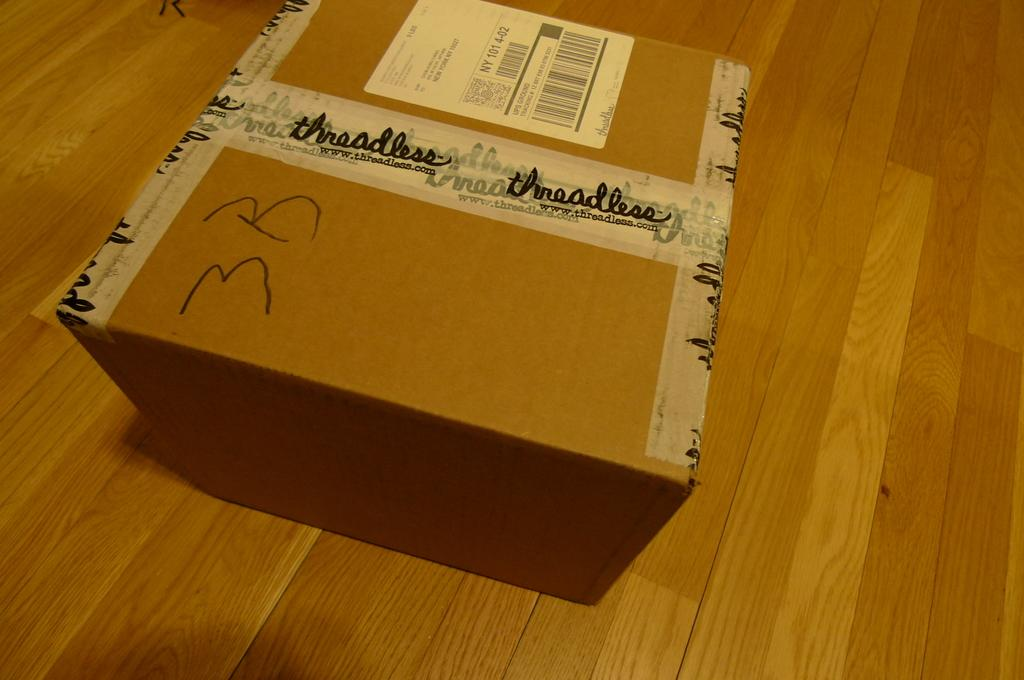<image>
Relay a brief, clear account of the picture shown. A package has been delivered from a company called Threadless. 